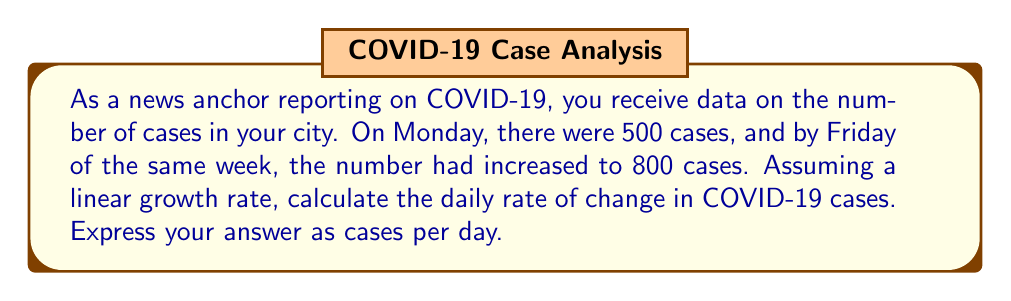Provide a solution to this math problem. To solve this problem, we need to use the formula for the rate of change:

$$\text{Rate of change} = \frac{\text{Change in y}}{\text{Change in x}}$$

Where:
- Change in y = Final value - Initial value
- Change in x = Number of time units

Let's break it down step-by-step:

1. Identify the given information:
   - Initial value (Monday): 500 cases
   - Final value (Friday): 800 cases
   - Time period: 5 days (Monday to Friday, inclusive)

2. Calculate the change in y (number of cases):
   $$\text{Change in y} = 800 - 500 = 300 \text{ cases}$$

3. Determine the change in x (time):
   $$\text{Change in x} = 5 - 1 = 4 \text{ days}$$
   (We use 4 days because we're calculating the daily rate, and there are 4 intervals between Monday and Friday)

4. Apply the rate of change formula:
   $$\text{Rate of change} = \frac{300 \text{ cases}}{4 \text{ days}} = 75 \text{ cases per day}$$

Therefore, the daily rate of change in COVID-19 cases is 75 cases per day.
Answer: 75 cases per day 